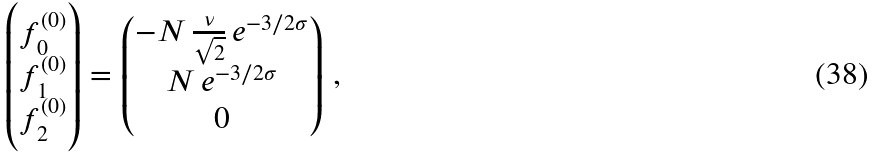<formula> <loc_0><loc_0><loc_500><loc_500>\begin{pmatrix} f _ { 0 } ^ { ( 0 ) } \\ f _ { 1 } ^ { ( 0 ) } \\ f _ { 2 } ^ { ( 0 ) } \end{pmatrix} = \begin{pmatrix} - N \, \frac { \nu } { \sqrt { 2 } } \, e ^ { - 3 / 2 \sigma } \\ N \, e ^ { - 3 / 2 \sigma } \\ 0 \end{pmatrix} \, ,</formula> 